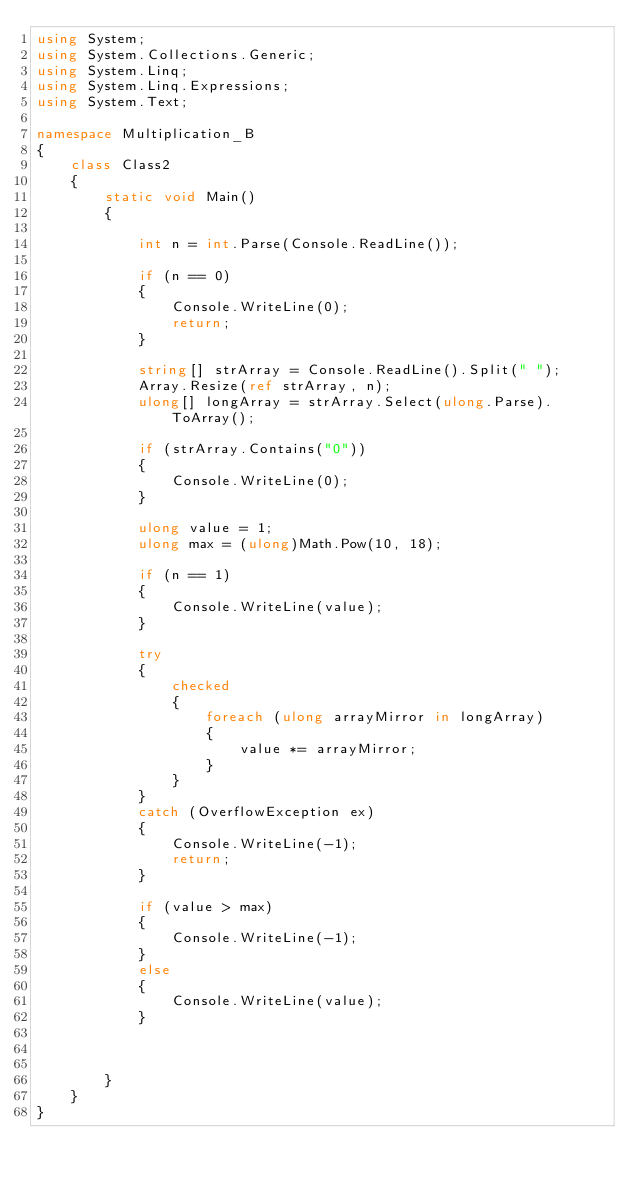<code> <loc_0><loc_0><loc_500><loc_500><_C#_>using System;
using System.Collections.Generic;
using System.Linq;
using System.Linq.Expressions;
using System.Text;

namespace Multiplication_B
{
    class Class2
    {
        static void Main()
        {

            int n = int.Parse(Console.ReadLine());

            if (n == 0)
            {
                Console.WriteLine(0);
                return;
            }

            string[] strArray = Console.ReadLine().Split(" ");
            Array.Resize(ref strArray, n);
            ulong[] longArray = strArray.Select(ulong.Parse).ToArray();

            if (strArray.Contains("0"))
            {
                Console.WriteLine(0);
            }

            ulong value = 1;
            ulong max = (ulong)Math.Pow(10, 18);

            if (n == 1)
            {
                Console.WriteLine(value);
            }

            try
            {
                checked
                {
                    foreach (ulong arrayMirror in longArray)
                    {
                        value *= arrayMirror;
                    }
                }
            }
            catch (OverflowException ex)
            {
                Console.WriteLine(-1);
                return;
            }

            if (value > max)
            {
                Console.WriteLine(-1);
            }
            else
            {
                Console.WriteLine(value);
            }



        }
    }
}
</code> 